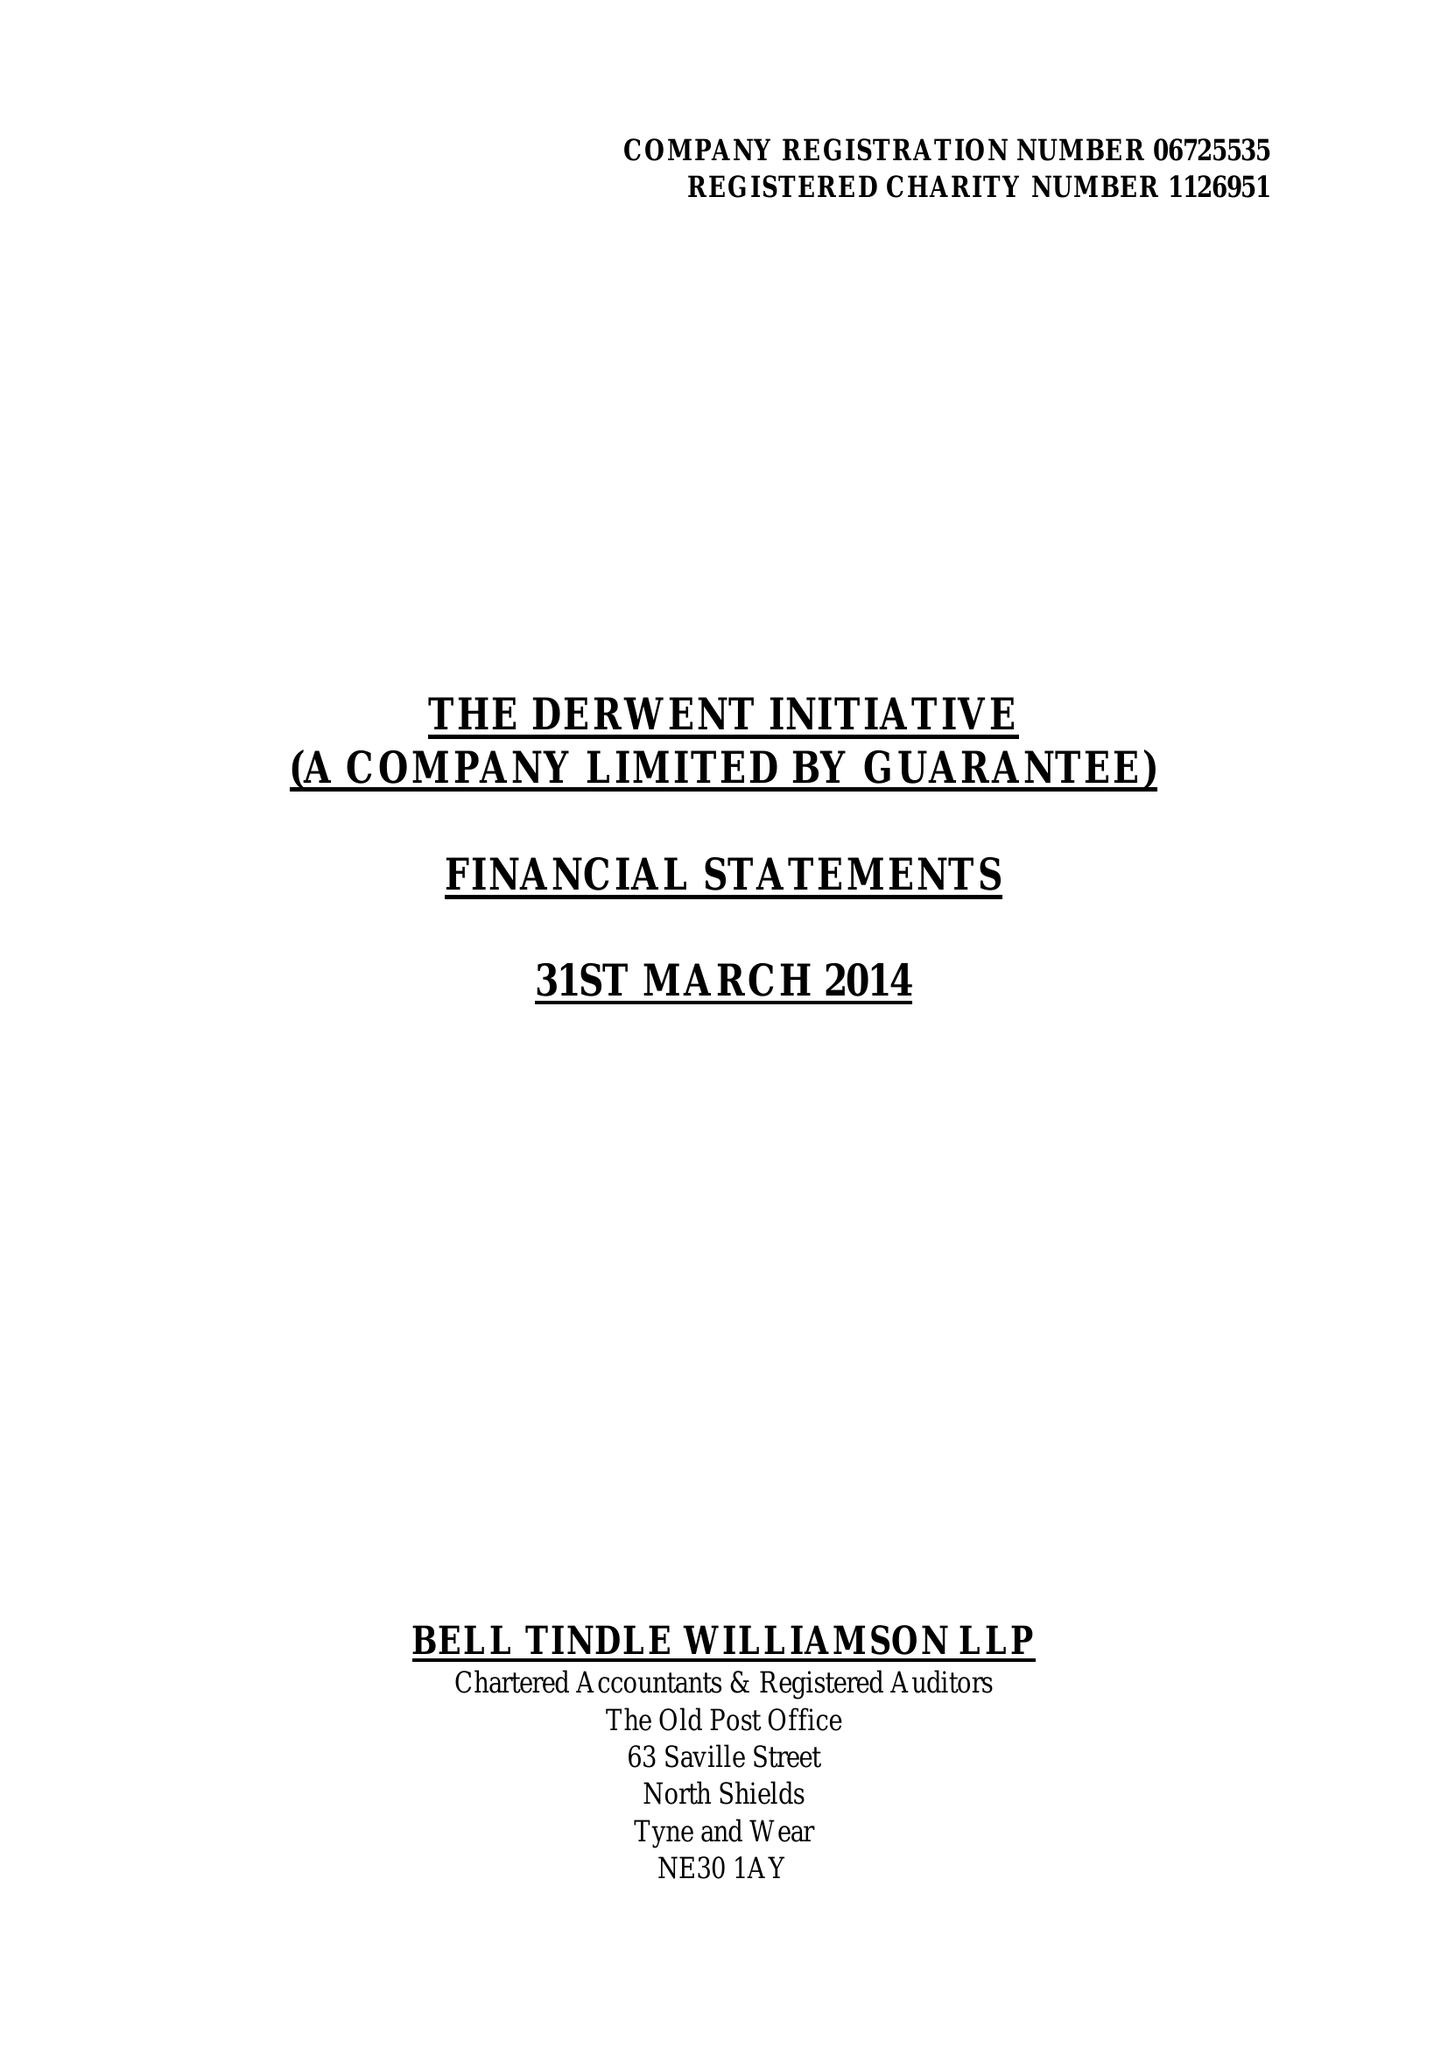What is the value for the charity_name?
Answer the question using a single word or phrase. The Derwent Initiative Ltd. 